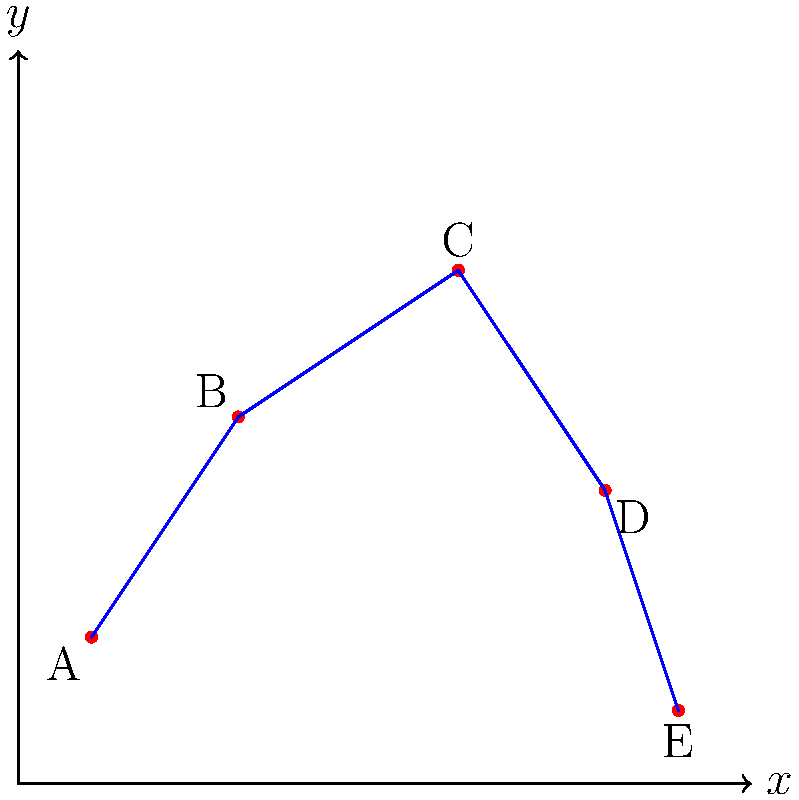Remember our favorite bike trail? I've plotted the key points on this coordinate system. If we start at point A and follow the trail to point E, what's the total distance we would bike? Round your answer to the nearest whole number. Let's approach this step-by-step:

1) First, we need to identify the coordinates of each point:
   A(1,2), B(3,5), C(6,7), D(8,4), E(9,1)

2) To find the total distance, we'll calculate the distance between each consecutive pair of points and sum them up.

3) We can use the distance formula: $d = \sqrt{(x_2-x_1)^2 + (y_2-y_1)^2}$

4) Let's calculate each segment:

   AB: $\sqrt{(3-1)^2 + (5-2)^2} = \sqrt{4 + 9} = \sqrt{13} \approx 3.61$
   BC: $\sqrt{(6-3)^2 + (7-5)^2} = \sqrt{9 + 4} = \sqrt{13} \approx 3.61$
   CD: $\sqrt{(8-6)^2 + (4-7)^2} = \sqrt{4 + 9} = \sqrt{13} \approx 3.61$
   DE: $\sqrt{(9-8)^2 + (1-4)^2} = \sqrt{1 + 9} = \sqrt{10} \approx 3.16$

5) Now, let's sum up all these distances:
   $3.61 + 3.61 + 3.61 + 3.16 = 13.99$

6) Rounding to the nearest whole number, we get 14.
Answer: 14 units 